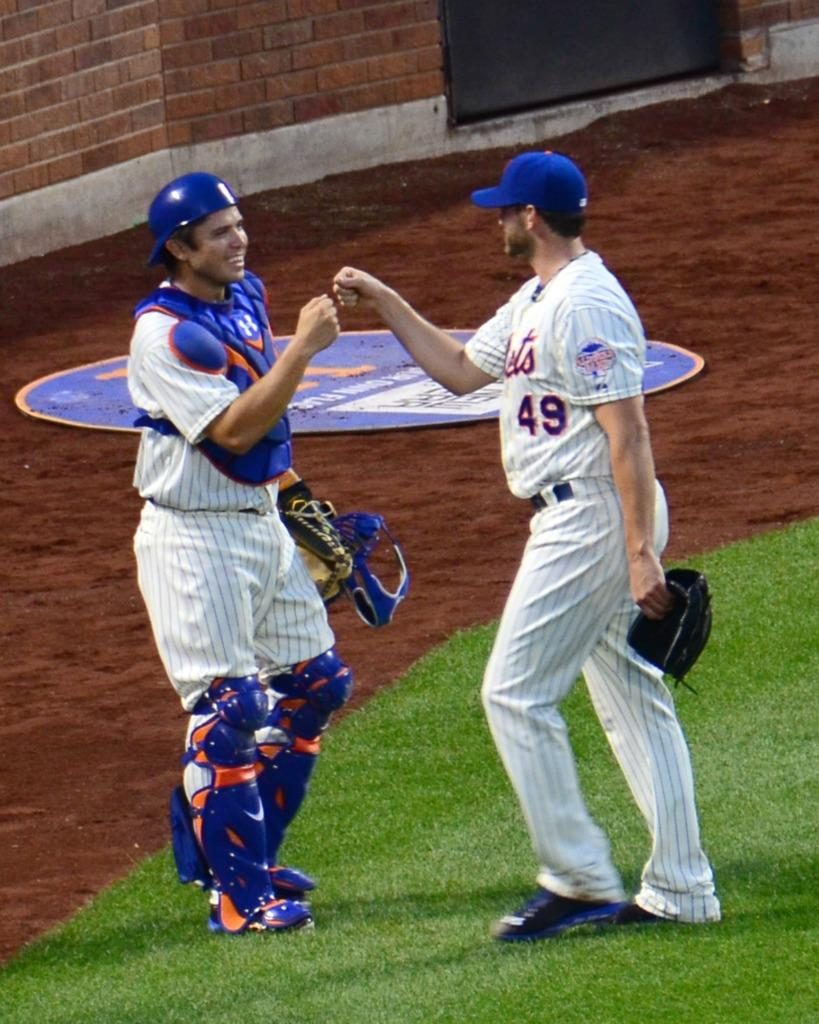<image>
Summarize the visual content of the image. a player with the number 49 on their Mets jersey 